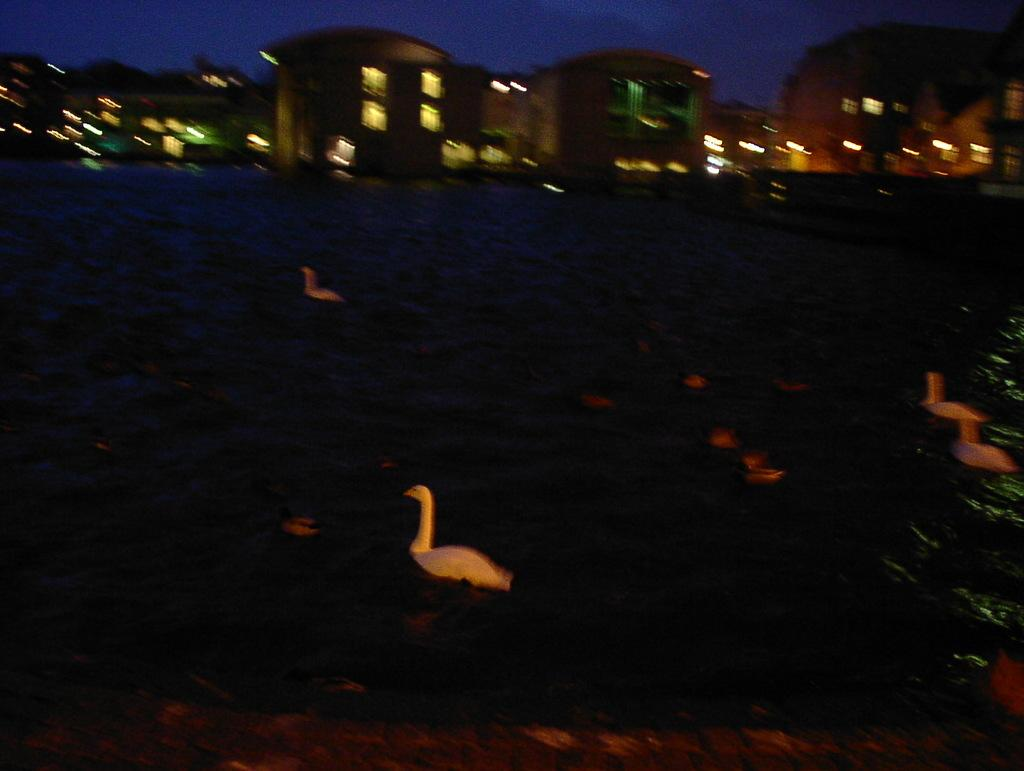What type of animals are in the water in the image? There are ducks in the water in the image. What else can be seen in the image besides the ducks? Buildings are visible in the image. What is visible in the background of the image? The sky is visible in the background of the image. What type of locket is the duck wearing in the image? There are no ducks wearing a locket in the image; the ducks are not depicted with any accessories. 